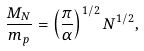Convert formula to latex. <formula><loc_0><loc_0><loc_500><loc_500>\frac { M _ { N } } { m _ { p } } = \left ( \frac { \pi } { \alpha } \right ) ^ { 1 / 2 } N ^ { 1 / 2 } ,</formula> 